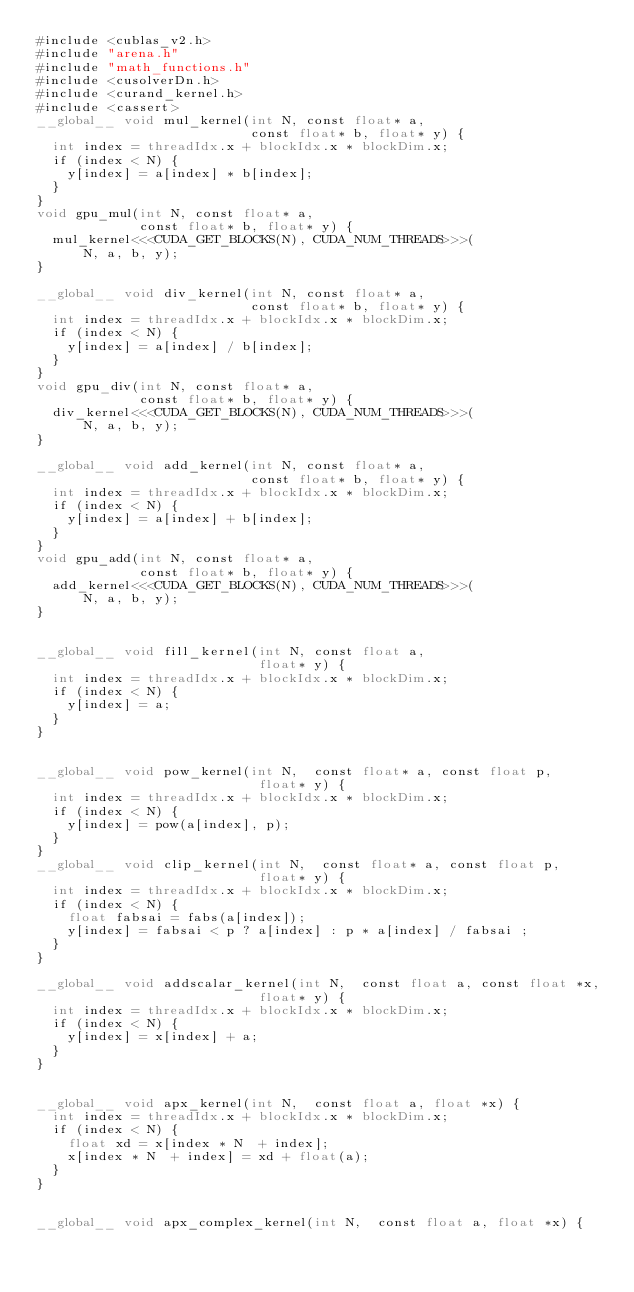Convert code to text. <code><loc_0><loc_0><loc_500><loc_500><_Cuda_>#include <cublas_v2.h>
#include "arena.h"
#include "math_functions.h"
#include <cusolverDn.h>
#include <curand_kernel.h>
#include <cassert>
__global__ void mul_kernel(int N, const float* a,
                           const float* b, float* y) {
  int index = threadIdx.x + blockIdx.x * blockDim.x;
  if (index < N) {
    y[index] = a[index] * b[index];
  }
}
void gpu_mul(int N, const float* a,
             const float* b, float* y) {
  mul_kernel<<<CUDA_GET_BLOCKS(N), CUDA_NUM_THREADS>>>(
      N, a, b, y);
}

__global__ void div_kernel(int N, const float* a,
                           const float* b, float* y) {
  int index = threadIdx.x + blockIdx.x * blockDim.x;
  if (index < N) {
    y[index] = a[index] / b[index];
  }
}
void gpu_div(int N, const float* a,
             const float* b, float* y) {
  div_kernel<<<CUDA_GET_BLOCKS(N), CUDA_NUM_THREADS>>>(
      N, a, b, y);
}

__global__ void add_kernel(int N, const float* a,
                           const float* b, float* y) {
  int index = threadIdx.x + blockIdx.x * blockDim.x;
  if (index < N) {
    y[index] = a[index] + b[index];
  }
}
void gpu_add(int N, const float* a,
             const float* b, float* y) {
  add_kernel<<<CUDA_GET_BLOCKS(N), CUDA_NUM_THREADS>>>(
      N, a, b, y);
}


__global__ void fill_kernel(int N, const float a,
                            float* y) {
  int index = threadIdx.x + blockIdx.x * blockDim.x;
  if (index < N) {
    y[index] = a;
  }
}


__global__ void pow_kernel(int N,  const float* a, const float p,
                            float* y) {
  int index = threadIdx.x + blockIdx.x * blockDim.x;
  if (index < N) {
    y[index] = pow(a[index], p);
  }
}
__global__ void clip_kernel(int N,  const float* a, const float p,
                            float* y) {
  int index = threadIdx.x + blockIdx.x * blockDim.x;
  if (index < N) {
    float fabsai = fabs(a[index]);
    y[index] = fabsai < p ? a[index] : p * a[index] / fabsai ;
  }
}

__global__ void addscalar_kernel(int N,  const float a, const float *x,
                            float* y) {
  int index = threadIdx.x + blockIdx.x * blockDim.x;
  if (index < N) {
    y[index] = x[index] + a;
  }
}


__global__ void apx_kernel(int N,  const float a, float *x) {
  int index = threadIdx.x + blockIdx.x * blockDim.x;
  if (index < N) {
    float xd = x[index * N  + index];
    x[index * N  + index] = xd + float(a);
  }
}


__global__ void apx_complex_kernel(int N,  const float a, float *x) {</code> 